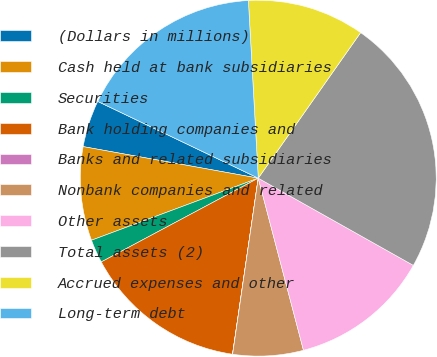Convert chart to OTSL. <chart><loc_0><loc_0><loc_500><loc_500><pie_chart><fcel>(Dollars in millions)<fcel>Cash held at bank subsidiaries<fcel>Securities<fcel>Bank holding companies and<fcel>Banks and related subsidiaries<fcel>Nonbank companies and related<fcel>Other assets<fcel>Total assets (2)<fcel>Accrued expenses and other<fcel>Long-term debt<nl><fcel>4.26%<fcel>8.51%<fcel>2.13%<fcel>14.89%<fcel>0.01%<fcel>6.39%<fcel>12.76%<fcel>23.4%<fcel>10.64%<fcel>17.02%<nl></chart> 